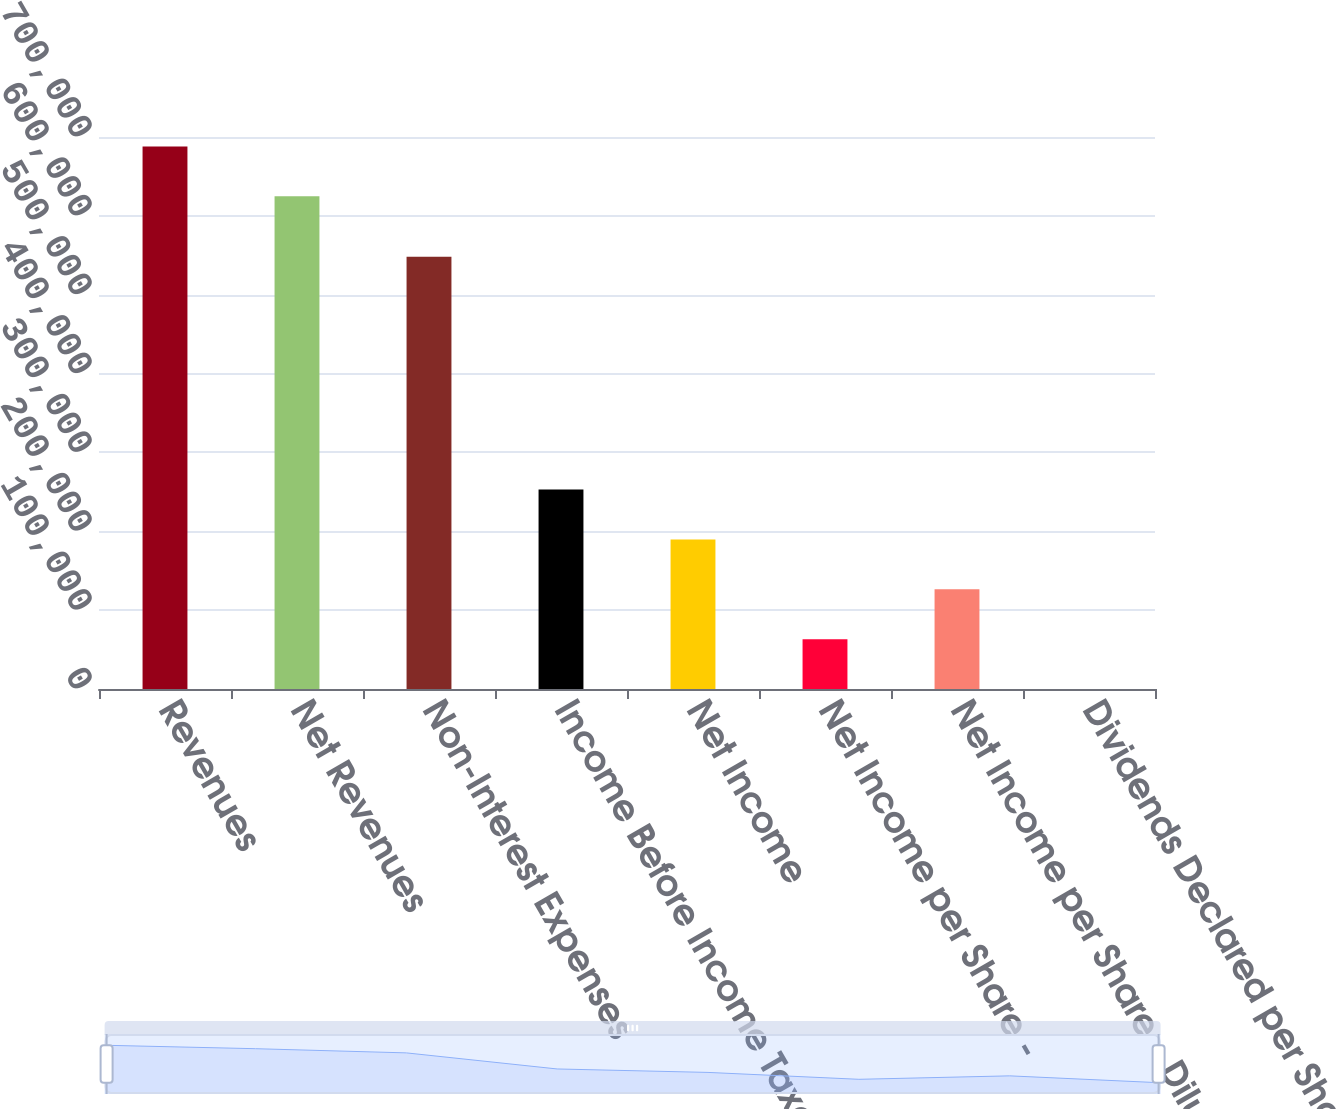Convert chart to OTSL. <chart><loc_0><loc_0><loc_500><loc_500><bar_chart><fcel>Revenues<fcel>Net Revenues<fcel>Non-Interest Expenses<fcel>Income Before Income Taxes<fcel>Net Income<fcel>Net Income per Share -<fcel>Net Income per Share - Diluted<fcel>Dividends Declared per Share<nl><fcel>688024<fcel>624799<fcel>548109<fcel>252901<fcel>189676<fcel>63225.3<fcel>126450<fcel>0.11<nl></chart> 